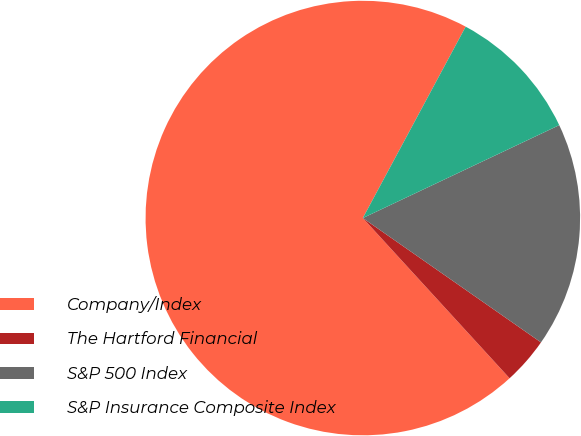Convert chart. <chart><loc_0><loc_0><loc_500><loc_500><pie_chart><fcel>Company/Index<fcel>The Hartford Financial<fcel>S&P 500 Index<fcel>S&P Insurance Composite Index<nl><fcel>69.65%<fcel>3.5%<fcel>16.73%<fcel>10.12%<nl></chart> 